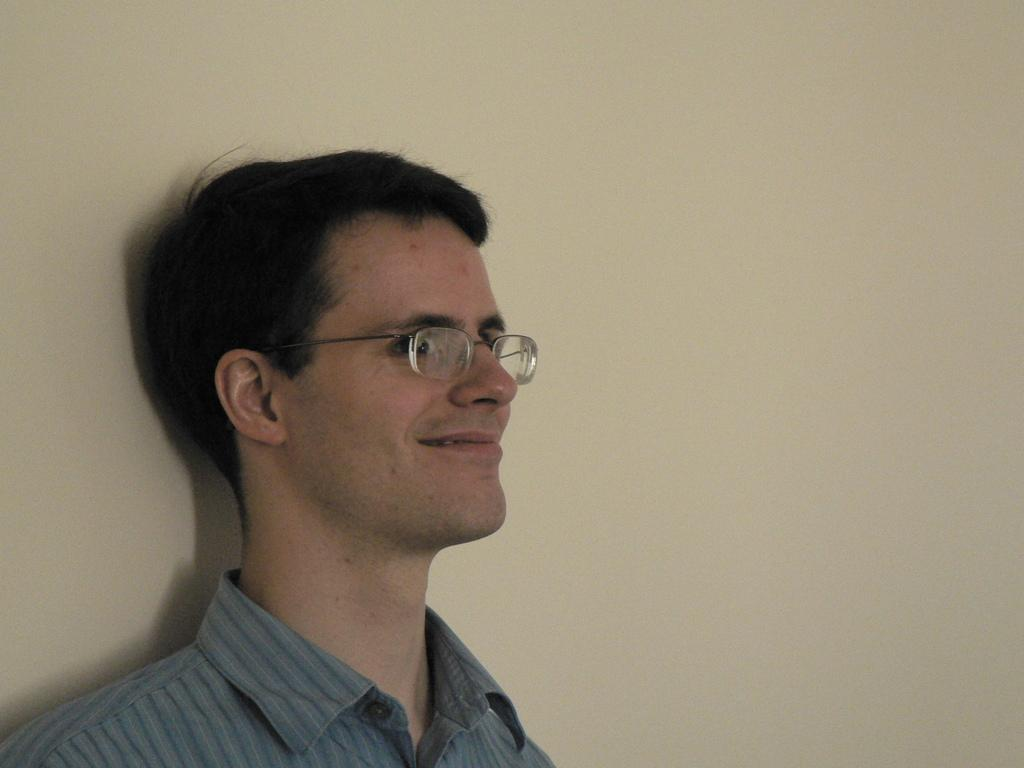Who or what is the main subject in the image? There is a person in the image. Can you describe the person's location in the image? The person is present over a place. What accessory is the person wearing in the image? The person is wearing spectacles. How is the person's facial expression in the image? The person is smiling. What type of wheel is visible in the image? There is no wheel present in the image. How does the person provide shade in the image? The person does not provide shade in the image; they are simply present over a place. 